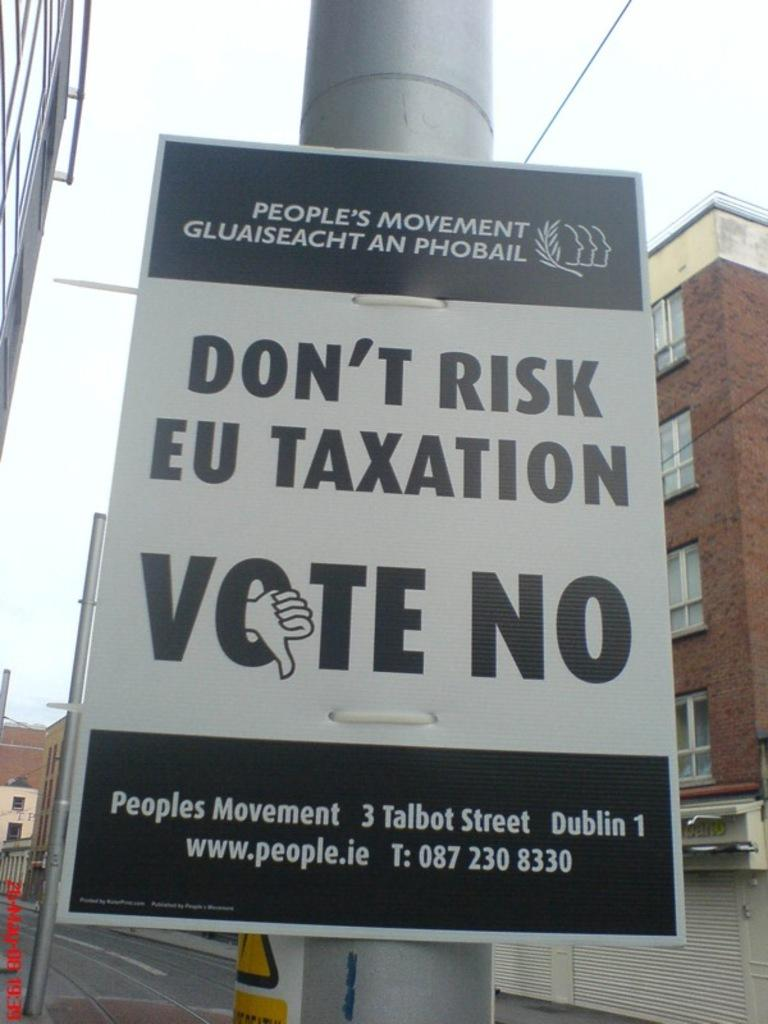<image>
Present a compact description of the photo's key features. a sign that says to vote no on it 